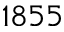Convert formula to latex. <formula><loc_0><loc_0><loc_500><loc_500>1 8 5 5</formula> 